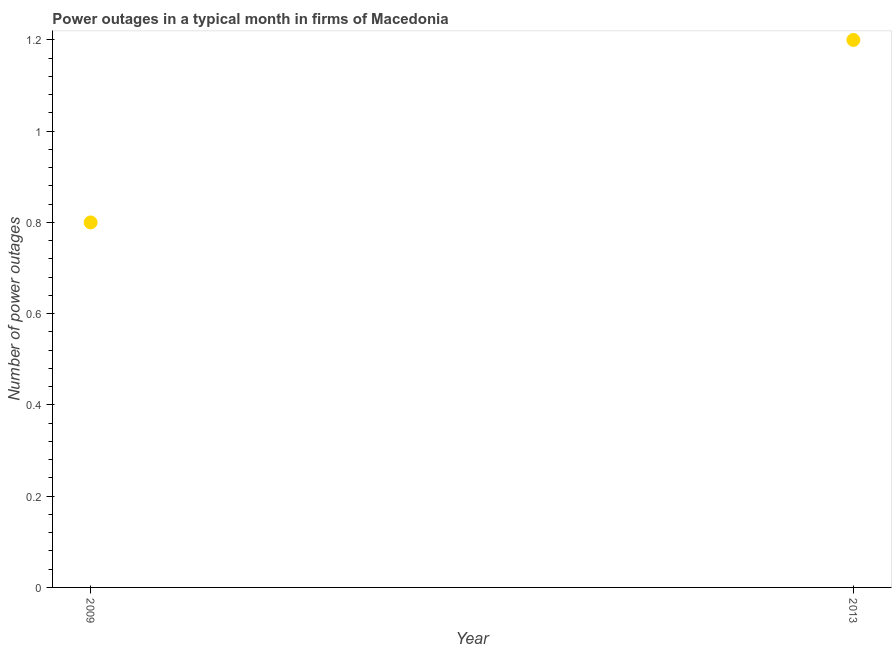What is the number of power outages in 2013?
Keep it short and to the point. 1.2. What is the difference between the number of power outages in 2009 and 2013?
Your answer should be compact. -0.4. What is the average number of power outages per year?
Offer a very short reply. 1. What is the median number of power outages?
Your answer should be compact. 1. What is the ratio of the number of power outages in 2009 to that in 2013?
Provide a succinct answer. 0.67. Is the number of power outages in 2009 less than that in 2013?
Make the answer very short. Yes. Does the number of power outages monotonically increase over the years?
Offer a very short reply. Yes. What is the difference between two consecutive major ticks on the Y-axis?
Keep it short and to the point. 0.2. Does the graph contain any zero values?
Your response must be concise. No. What is the title of the graph?
Offer a terse response. Power outages in a typical month in firms of Macedonia. What is the label or title of the Y-axis?
Your answer should be very brief. Number of power outages. What is the Number of power outages in 2013?
Ensure brevity in your answer.  1.2. What is the difference between the Number of power outages in 2009 and 2013?
Give a very brief answer. -0.4. What is the ratio of the Number of power outages in 2009 to that in 2013?
Make the answer very short. 0.67. 